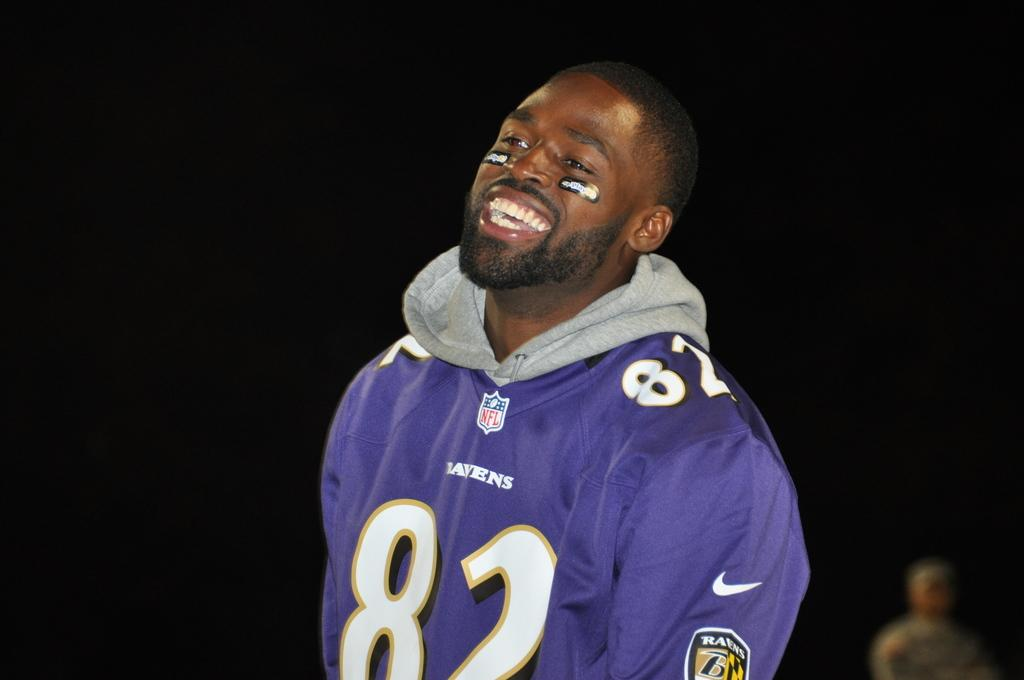<image>
Describe the image concisely. A man with face paint under his eyes is wearing a purple Ravens sweater with the number 82 on it. 